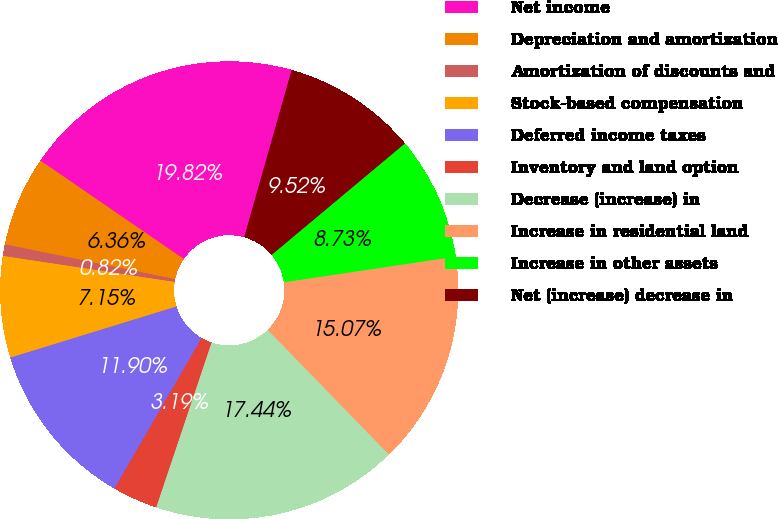<chart> <loc_0><loc_0><loc_500><loc_500><pie_chart><fcel>Net income<fcel>Depreciation and amortization<fcel>Amortization of discounts and<fcel>Stock-based compensation<fcel>Deferred income taxes<fcel>Inventory and land option<fcel>Decrease (increase) in<fcel>Increase in residential land<fcel>Increase in other assets<fcel>Net (increase) decrease in<nl><fcel>19.82%<fcel>6.36%<fcel>0.82%<fcel>7.15%<fcel>11.9%<fcel>3.19%<fcel>17.44%<fcel>15.07%<fcel>8.73%<fcel>9.52%<nl></chart> 